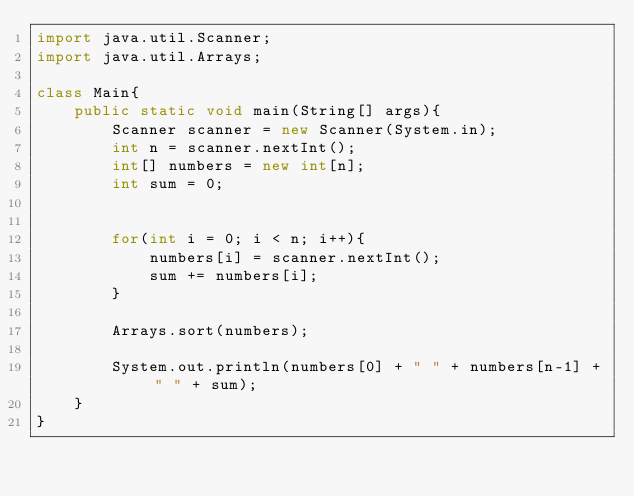<code> <loc_0><loc_0><loc_500><loc_500><_Java_>import java.util.Scanner;
import java.util.Arrays;

class Main{
	public static void main(String[] args){
		Scanner scanner = new Scanner(System.in);
		int n = scanner.nextInt();
		int[] numbers = new int[n];
		int sum = 0;


		for(int i = 0; i < n; i++){
			numbers[i] = scanner.nextInt();
			sum += numbers[i];
		}

		Arrays.sort(numbers);

		System.out.println(numbers[0] + " " + numbers[n-1] + " " + sum);
	}
}</code> 